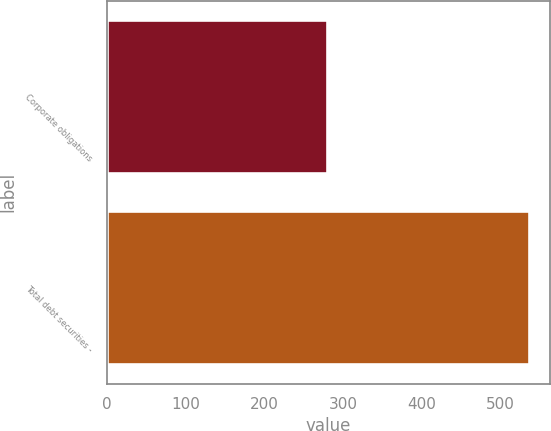Convert chart to OTSL. <chart><loc_0><loc_0><loc_500><loc_500><bar_chart><fcel>Corporate obligations<fcel>Total debt securities -<nl><fcel>280<fcel>536<nl></chart> 